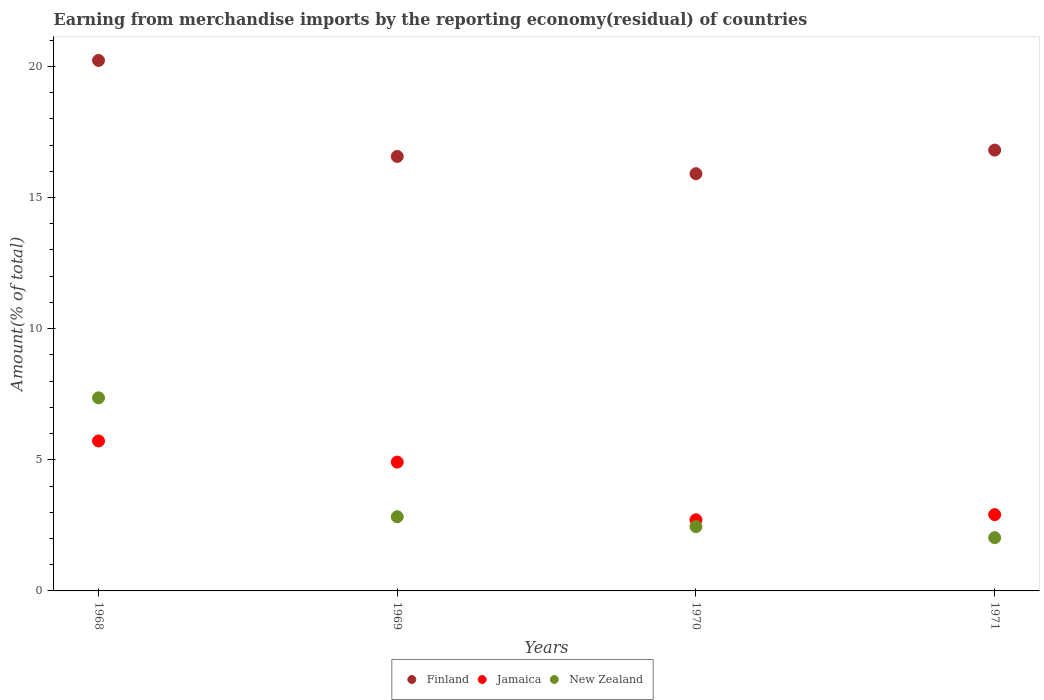Is the number of dotlines equal to the number of legend labels?
Provide a short and direct response. Yes. What is the percentage of amount earned from merchandise imports in New Zealand in 1968?
Offer a terse response. 7.36. Across all years, what is the maximum percentage of amount earned from merchandise imports in Finland?
Provide a short and direct response. 20.23. Across all years, what is the minimum percentage of amount earned from merchandise imports in New Zealand?
Provide a short and direct response. 2.03. In which year was the percentage of amount earned from merchandise imports in New Zealand maximum?
Keep it short and to the point. 1968. In which year was the percentage of amount earned from merchandise imports in New Zealand minimum?
Give a very brief answer. 1971. What is the total percentage of amount earned from merchandise imports in Jamaica in the graph?
Your answer should be very brief. 16.25. What is the difference between the percentage of amount earned from merchandise imports in Jamaica in 1968 and that in 1969?
Offer a very short reply. 0.81. What is the difference between the percentage of amount earned from merchandise imports in Finland in 1969 and the percentage of amount earned from merchandise imports in Jamaica in 1971?
Ensure brevity in your answer.  13.66. What is the average percentage of amount earned from merchandise imports in Finland per year?
Your answer should be very brief. 17.38. In the year 1968, what is the difference between the percentage of amount earned from merchandise imports in New Zealand and percentage of amount earned from merchandise imports in Jamaica?
Offer a very short reply. 1.64. In how many years, is the percentage of amount earned from merchandise imports in New Zealand greater than 14 %?
Ensure brevity in your answer.  0. What is the ratio of the percentage of amount earned from merchandise imports in Finland in 1969 to that in 1970?
Your answer should be very brief. 1.04. Is the percentage of amount earned from merchandise imports in Jamaica in 1968 less than that in 1969?
Offer a terse response. No. Is the difference between the percentage of amount earned from merchandise imports in New Zealand in 1970 and 1971 greater than the difference between the percentage of amount earned from merchandise imports in Jamaica in 1970 and 1971?
Make the answer very short. Yes. What is the difference between the highest and the second highest percentage of amount earned from merchandise imports in Jamaica?
Keep it short and to the point. 0.81. What is the difference between the highest and the lowest percentage of amount earned from merchandise imports in New Zealand?
Make the answer very short. 5.33. In how many years, is the percentage of amount earned from merchandise imports in Finland greater than the average percentage of amount earned from merchandise imports in Finland taken over all years?
Offer a very short reply. 1. Is it the case that in every year, the sum of the percentage of amount earned from merchandise imports in Finland and percentage of amount earned from merchandise imports in Jamaica  is greater than the percentage of amount earned from merchandise imports in New Zealand?
Your response must be concise. Yes. Is the percentage of amount earned from merchandise imports in Jamaica strictly greater than the percentage of amount earned from merchandise imports in New Zealand over the years?
Ensure brevity in your answer.  No. How many dotlines are there?
Ensure brevity in your answer.  3. How many years are there in the graph?
Provide a succinct answer. 4. Are the values on the major ticks of Y-axis written in scientific E-notation?
Your answer should be compact. No. How are the legend labels stacked?
Your response must be concise. Horizontal. What is the title of the graph?
Make the answer very short. Earning from merchandise imports by the reporting economy(residual) of countries. Does "Fragile and conflict affected situations" appear as one of the legend labels in the graph?
Make the answer very short. No. What is the label or title of the Y-axis?
Your answer should be very brief. Amount(% of total). What is the Amount(% of total) in Finland in 1968?
Your answer should be compact. 20.23. What is the Amount(% of total) of Jamaica in 1968?
Your answer should be compact. 5.72. What is the Amount(% of total) in New Zealand in 1968?
Offer a very short reply. 7.36. What is the Amount(% of total) of Finland in 1969?
Offer a very short reply. 16.57. What is the Amount(% of total) of Jamaica in 1969?
Provide a short and direct response. 4.91. What is the Amount(% of total) of New Zealand in 1969?
Your answer should be very brief. 2.83. What is the Amount(% of total) in Finland in 1970?
Provide a short and direct response. 15.91. What is the Amount(% of total) in Jamaica in 1970?
Provide a succinct answer. 2.71. What is the Amount(% of total) of New Zealand in 1970?
Provide a short and direct response. 2.45. What is the Amount(% of total) in Finland in 1971?
Your answer should be compact. 16.81. What is the Amount(% of total) of Jamaica in 1971?
Offer a very short reply. 2.91. What is the Amount(% of total) of New Zealand in 1971?
Ensure brevity in your answer.  2.03. Across all years, what is the maximum Amount(% of total) of Finland?
Your answer should be compact. 20.23. Across all years, what is the maximum Amount(% of total) of Jamaica?
Your answer should be compact. 5.72. Across all years, what is the maximum Amount(% of total) of New Zealand?
Ensure brevity in your answer.  7.36. Across all years, what is the minimum Amount(% of total) in Finland?
Your answer should be compact. 15.91. Across all years, what is the minimum Amount(% of total) of Jamaica?
Offer a very short reply. 2.71. Across all years, what is the minimum Amount(% of total) of New Zealand?
Ensure brevity in your answer.  2.03. What is the total Amount(% of total) of Finland in the graph?
Offer a very short reply. 69.51. What is the total Amount(% of total) in Jamaica in the graph?
Keep it short and to the point. 16.25. What is the total Amount(% of total) of New Zealand in the graph?
Provide a short and direct response. 14.67. What is the difference between the Amount(% of total) in Finland in 1968 and that in 1969?
Offer a very short reply. 3.66. What is the difference between the Amount(% of total) in Jamaica in 1968 and that in 1969?
Make the answer very short. 0.81. What is the difference between the Amount(% of total) in New Zealand in 1968 and that in 1969?
Make the answer very short. 4.53. What is the difference between the Amount(% of total) of Finland in 1968 and that in 1970?
Offer a terse response. 4.32. What is the difference between the Amount(% of total) in Jamaica in 1968 and that in 1970?
Make the answer very short. 3.01. What is the difference between the Amount(% of total) in New Zealand in 1968 and that in 1970?
Offer a very short reply. 4.91. What is the difference between the Amount(% of total) of Finland in 1968 and that in 1971?
Offer a terse response. 3.42. What is the difference between the Amount(% of total) of Jamaica in 1968 and that in 1971?
Your response must be concise. 2.81. What is the difference between the Amount(% of total) of New Zealand in 1968 and that in 1971?
Provide a short and direct response. 5.33. What is the difference between the Amount(% of total) of Finland in 1969 and that in 1970?
Ensure brevity in your answer.  0.66. What is the difference between the Amount(% of total) of Jamaica in 1969 and that in 1970?
Your answer should be very brief. 2.2. What is the difference between the Amount(% of total) in New Zealand in 1969 and that in 1970?
Offer a terse response. 0.38. What is the difference between the Amount(% of total) in Finland in 1969 and that in 1971?
Your answer should be compact. -0.24. What is the difference between the Amount(% of total) of Jamaica in 1969 and that in 1971?
Keep it short and to the point. 2. What is the difference between the Amount(% of total) in New Zealand in 1969 and that in 1971?
Offer a terse response. 0.8. What is the difference between the Amount(% of total) of Finland in 1970 and that in 1971?
Give a very brief answer. -0.9. What is the difference between the Amount(% of total) in Jamaica in 1970 and that in 1971?
Offer a terse response. -0.2. What is the difference between the Amount(% of total) of New Zealand in 1970 and that in 1971?
Keep it short and to the point. 0.42. What is the difference between the Amount(% of total) of Finland in 1968 and the Amount(% of total) of Jamaica in 1969?
Offer a terse response. 15.31. What is the difference between the Amount(% of total) in Finland in 1968 and the Amount(% of total) in New Zealand in 1969?
Offer a terse response. 17.4. What is the difference between the Amount(% of total) in Jamaica in 1968 and the Amount(% of total) in New Zealand in 1969?
Ensure brevity in your answer.  2.89. What is the difference between the Amount(% of total) of Finland in 1968 and the Amount(% of total) of Jamaica in 1970?
Keep it short and to the point. 17.51. What is the difference between the Amount(% of total) of Finland in 1968 and the Amount(% of total) of New Zealand in 1970?
Offer a terse response. 17.77. What is the difference between the Amount(% of total) of Jamaica in 1968 and the Amount(% of total) of New Zealand in 1970?
Offer a very short reply. 3.27. What is the difference between the Amount(% of total) in Finland in 1968 and the Amount(% of total) in Jamaica in 1971?
Provide a short and direct response. 17.32. What is the difference between the Amount(% of total) in Finland in 1968 and the Amount(% of total) in New Zealand in 1971?
Ensure brevity in your answer.  18.2. What is the difference between the Amount(% of total) of Jamaica in 1968 and the Amount(% of total) of New Zealand in 1971?
Provide a succinct answer. 3.69. What is the difference between the Amount(% of total) in Finland in 1969 and the Amount(% of total) in Jamaica in 1970?
Your response must be concise. 13.85. What is the difference between the Amount(% of total) in Finland in 1969 and the Amount(% of total) in New Zealand in 1970?
Provide a succinct answer. 14.11. What is the difference between the Amount(% of total) in Jamaica in 1969 and the Amount(% of total) in New Zealand in 1970?
Give a very brief answer. 2.46. What is the difference between the Amount(% of total) of Finland in 1969 and the Amount(% of total) of Jamaica in 1971?
Give a very brief answer. 13.66. What is the difference between the Amount(% of total) in Finland in 1969 and the Amount(% of total) in New Zealand in 1971?
Make the answer very short. 14.54. What is the difference between the Amount(% of total) of Jamaica in 1969 and the Amount(% of total) of New Zealand in 1971?
Keep it short and to the point. 2.88. What is the difference between the Amount(% of total) in Finland in 1970 and the Amount(% of total) in Jamaica in 1971?
Ensure brevity in your answer.  13. What is the difference between the Amount(% of total) of Finland in 1970 and the Amount(% of total) of New Zealand in 1971?
Provide a succinct answer. 13.88. What is the difference between the Amount(% of total) of Jamaica in 1970 and the Amount(% of total) of New Zealand in 1971?
Keep it short and to the point. 0.68. What is the average Amount(% of total) in Finland per year?
Ensure brevity in your answer.  17.38. What is the average Amount(% of total) in Jamaica per year?
Ensure brevity in your answer.  4.06. What is the average Amount(% of total) of New Zealand per year?
Ensure brevity in your answer.  3.67. In the year 1968, what is the difference between the Amount(% of total) of Finland and Amount(% of total) of Jamaica?
Give a very brief answer. 14.51. In the year 1968, what is the difference between the Amount(% of total) in Finland and Amount(% of total) in New Zealand?
Your answer should be very brief. 12.86. In the year 1968, what is the difference between the Amount(% of total) of Jamaica and Amount(% of total) of New Zealand?
Your answer should be compact. -1.64. In the year 1969, what is the difference between the Amount(% of total) in Finland and Amount(% of total) in Jamaica?
Offer a very short reply. 11.65. In the year 1969, what is the difference between the Amount(% of total) of Finland and Amount(% of total) of New Zealand?
Ensure brevity in your answer.  13.74. In the year 1969, what is the difference between the Amount(% of total) in Jamaica and Amount(% of total) in New Zealand?
Keep it short and to the point. 2.08. In the year 1970, what is the difference between the Amount(% of total) of Finland and Amount(% of total) of Jamaica?
Make the answer very short. 13.2. In the year 1970, what is the difference between the Amount(% of total) in Finland and Amount(% of total) in New Zealand?
Provide a succinct answer. 13.46. In the year 1970, what is the difference between the Amount(% of total) of Jamaica and Amount(% of total) of New Zealand?
Provide a short and direct response. 0.26. In the year 1971, what is the difference between the Amount(% of total) of Finland and Amount(% of total) of Jamaica?
Ensure brevity in your answer.  13.9. In the year 1971, what is the difference between the Amount(% of total) in Finland and Amount(% of total) in New Zealand?
Ensure brevity in your answer.  14.78. In the year 1971, what is the difference between the Amount(% of total) of Jamaica and Amount(% of total) of New Zealand?
Give a very brief answer. 0.88. What is the ratio of the Amount(% of total) in Finland in 1968 to that in 1969?
Provide a succinct answer. 1.22. What is the ratio of the Amount(% of total) in Jamaica in 1968 to that in 1969?
Make the answer very short. 1.16. What is the ratio of the Amount(% of total) of New Zealand in 1968 to that in 1969?
Make the answer very short. 2.6. What is the ratio of the Amount(% of total) of Finland in 1968 to that in 1970?
Ensure brevity in your answer.  1.27. What is the ratio of the Amount(% of total) of Jamaica in 1968 to that in 1970?
Provide a short and direct response. 2.11. What is the ratio of the Amount(% of total) of New Zealand in 1968 to that in 1970?
Your answer should be compact. 3. What is the ratio of the Amount(% of total) of Finland in 1968 to that in 1971?
Offer a terse response. 1.2. What is the ratio of the Amount(% of total) of Jamaica in 1968 to that in 1971?
Make the answer very short. 1.97. What is the ratio of the Amount(% of total) of New Zealand in 1968 to that in 1971?
Keep it short and to the point. 3.63. What is the ratio of the Amount(% of total) of Finland in 1969 to that in 1970?
Offer a terse response. 1.04. What is the ratio of the Amount(% of total) of Jamaica in 1969 to that in 1970?
Offer a very short reply. 1.81. What is the ratio of the Amount(% of total) in New Zealand in 1969 to that in 1970?
Offer a terse response. 1.15. What is the ratio of the Amount(% of total) in Finland in 1969 to that in 1971?
Provide a short and direct response. 0.99. What is the ratio of the Amount(% of total) of Jamaica in 1969 to that in 1971?
Make the answer very short. 1.69. What is the ratio of the Amount(% of total) in New Zealand in 1969 to that in 1971?
Provide a succinct answer. 1.39. What is the ratio of the Amount(% of total) of Finland in 1970 to that in 1971?
Your answer should be very brief. 0.95. What is the ratio of the Amount(% of total) in Jamaica in 1970 to that in 1971?
Make the answer very short. 0.93. What is the ratio of the Amount(% of total) of New Zealand in 1970 to that in 1971?
Your answer should be very brief. 1.21. What is the difference between the highest and the second highest Amount(% of total) of Finland?
Make the answer very short. 3.42. What is the difference between the highest and the second highest Amount(% of total) of Jamaica?
Offer a very short reply. 0.81. What is the difference between the highest and the second highest Amount(% of total) of New Zealand?
Keep it short and to the point. 4.53. What is the difference between the highest and the lowest Amount(% of total) in Finland?
Your response must be concise. 4.32. What is the difference between the highest and the lowest Amount(% of total) of Jamaica?
Offer a terse response. 3.01. What is the difference between the highest and the lowest Amount(% of total) in New Zealand?
Offer a very short reply. 5.33. 